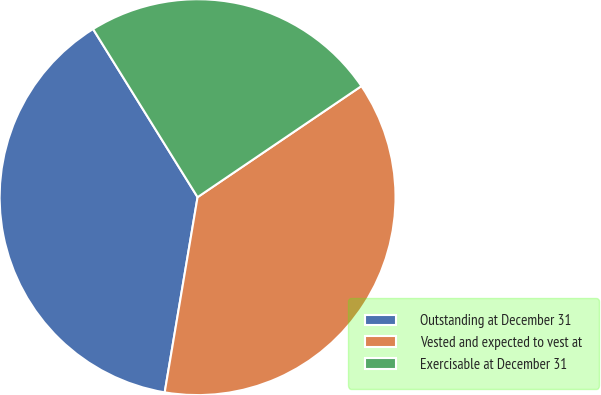Convert chart. <chart><loc_0><loc_0><loc_500><loc_500><pie_chart><fcel>Outstanding at December 31<fcel>Vested and expected to vest at<fcel>Exercisable at December 31<nl><fcel>38.49%<fcel>37.14%<fcel>24.37%<nl></chart> 